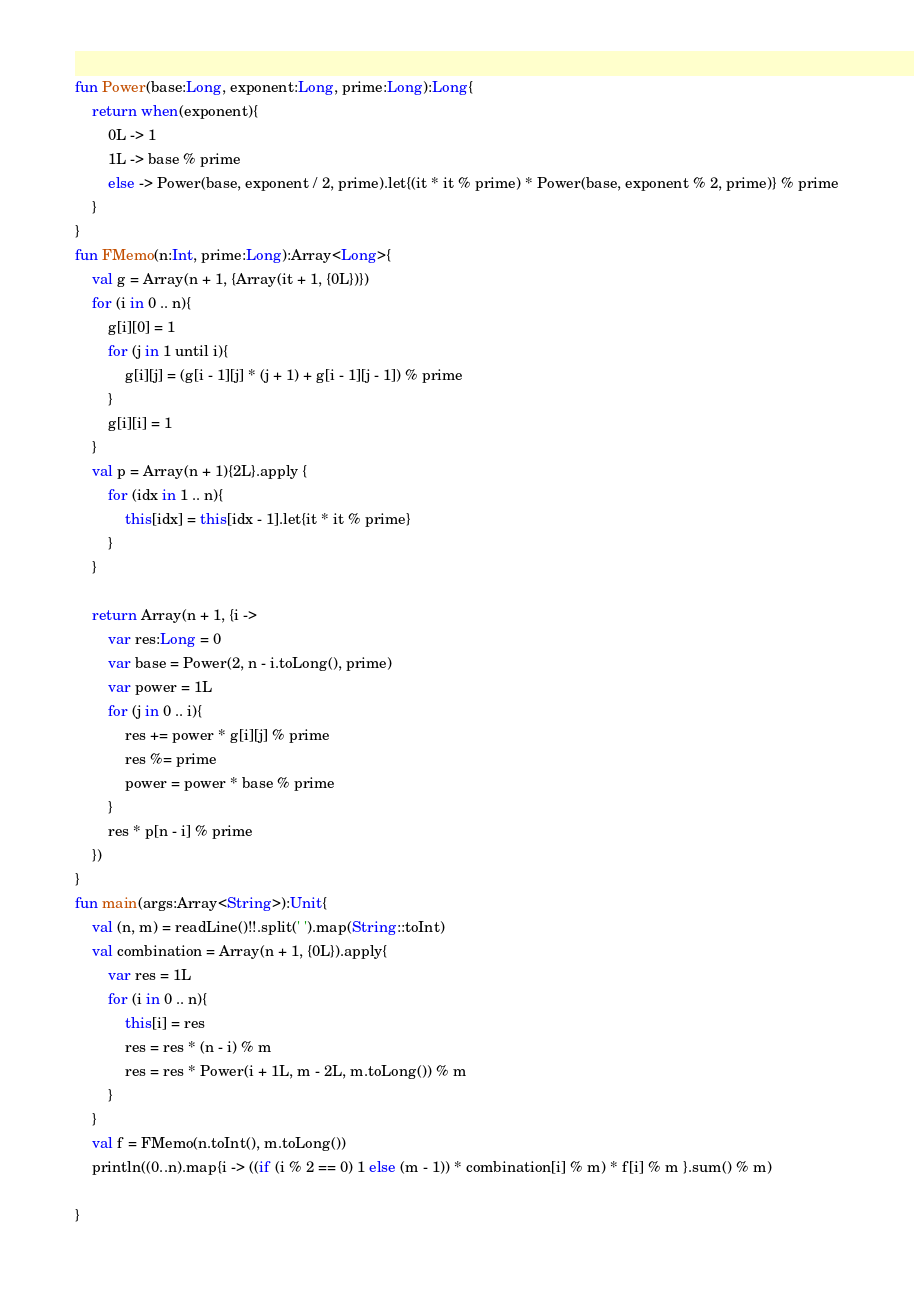Convert code to text. <code><loc_0><loc_0><loc_500><loc_500><_Kotlin_>fun Power(base:Long, exponent:Long, prime:Long):Long{
    return when(exponent){
        0L -> 1
        1L -> base % prime
        else -> Power(base, exponent / 2, prime).let{(it * it % prime) * Power(base, exponent % 2, prime)} % prime
    }
}
fun FMemo(n:Int, prime:Long):Array<Long>{
    val g = Array(n + 1, {Array(it + 1, {0L})})
    for (i in 0 .. n){
        g[i][0] = 1
        for (j in 1 until i){
            g[i][j] = (g[i - 1][j] * (j + 1) + g[i - 1][j - 1]) % prime
        }
        g[i][i] = 1
    }
    val p = Array(n + 1){2L}.apply {
        for (idx in 1 .. n){
            this[idx] = this[idx - 1].let{it * it % prime}
        }
    }

    return Array(n + 1, {i ->
        var res:Long = 0
        var base = Power(2, n - i.toLong(), prime)
        var power = 1L
        for (j in 0 .. i){
            res += power * g[i][j] % prime
            res %= prime
            power = power * base % prime
        }
        res * p[n - i] % prime
    })
}
fun main(args:Array<String>):Unit{
    val (n, m) = readLine()!!.split(' ').map(String::toInt)
    val combination = Array(n + 1, {0L}).apply{
        var res = 1L
        for (i in 0 .. n){
            this[i] = res
            res = res * (n - i) % m
            res = res * Power(i + 1L, m - 2L, m.toLong()) % m
        }
    }
    val f = FMemo(n.toInt(), m.toLong())
    println((0..n).map{i -> ((if (i % 2 == 0) 1 else (m - 1)) * combination[i] % m) * f[i] % m }.sum() % m)

}</code> 